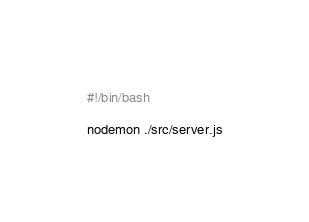<code> <loc_0><loc_0><loc_500><loc_500><_Bash_>#!/bin/bash

nodemon ./src/server.js</code> 